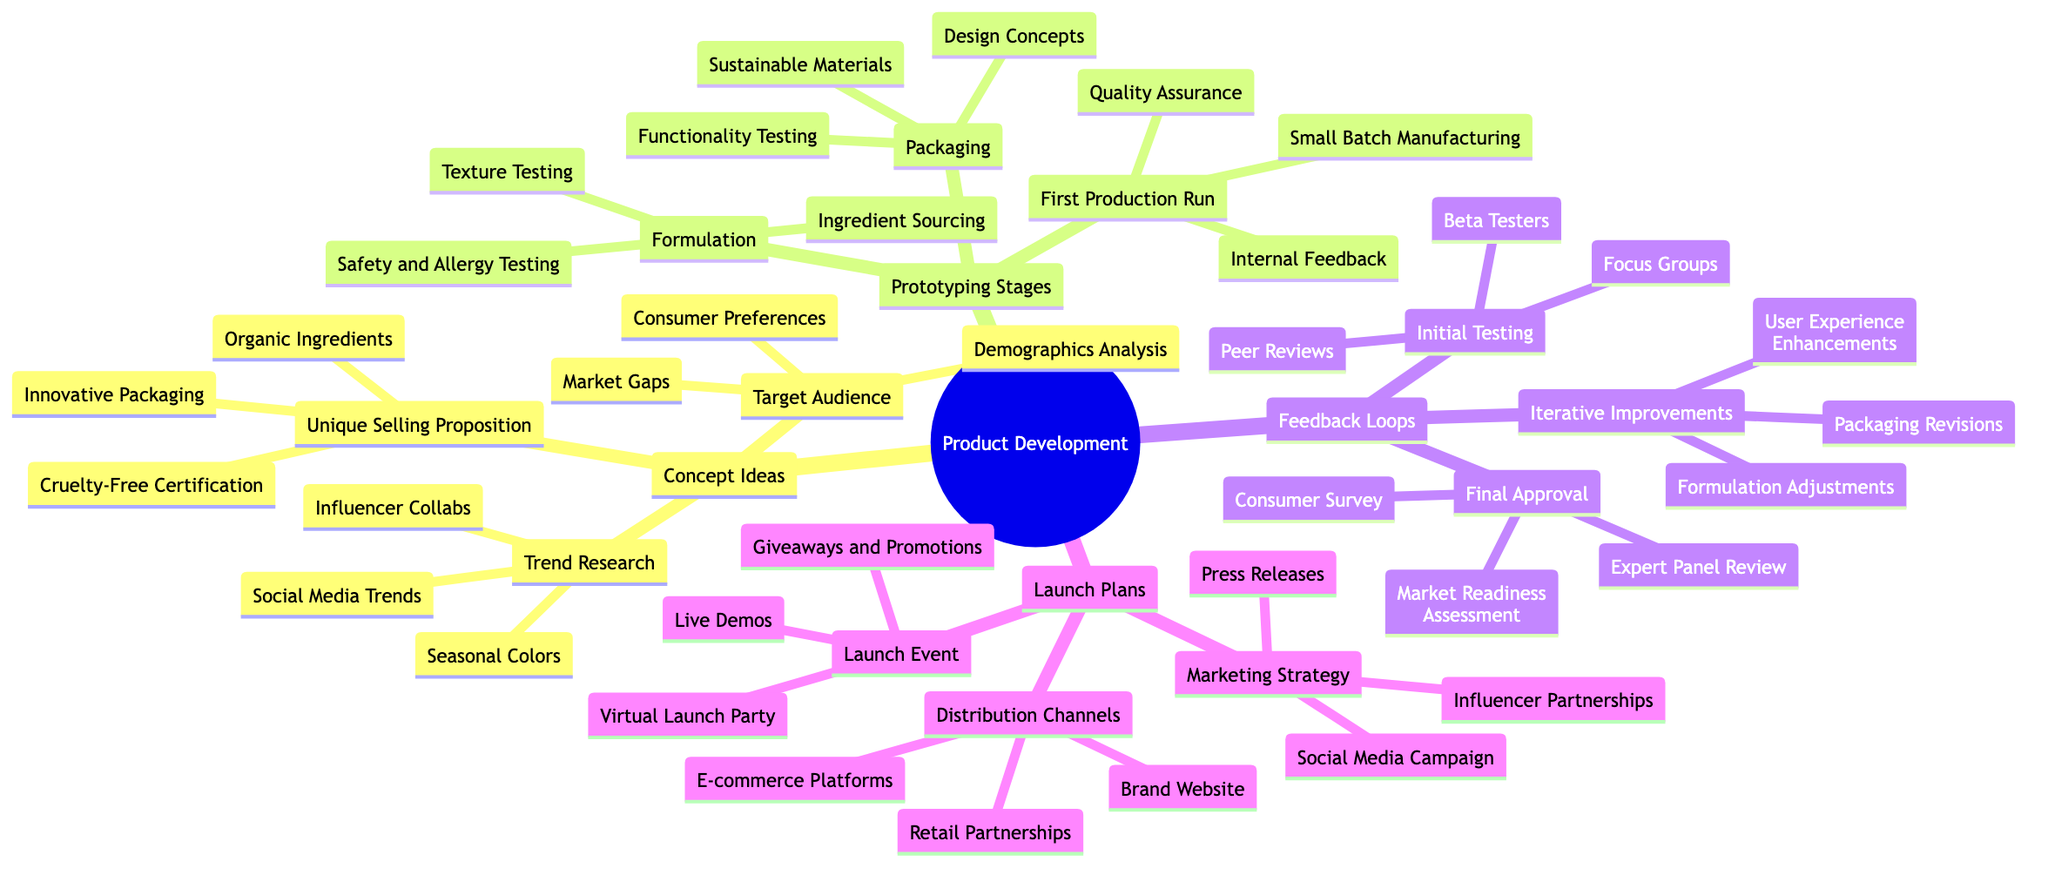What are the three components of Concept Ideas? The three components listed under Concept Ideas are Trend Research, Unique Selling Proposition, and Target Audience.
Answer: Trend Research, Unique Selling Proposition, Target Audience How many items are listed under Prototyping Stages? There are three main nodes under Prototyping Stages: Formulation, Packaging, and First Production Run. Each of these nodes has three associated items, making a total of nine items.
Answer: Nine What is one type of Initial Testing? One type of Initial Testing mentioned is Focus Groups, which helps gather user feedback.
Answer: Focus Groups Which selling proposition emphasizes ethical practices? The Cruelty-Free Certification highlights ethical practices within the Unique Selling Proposition category.
Answer: Cruelty-Free Certification What is the final step in Feedback Loops? The last step listed in Feedback Loops is Final Approval, where the product is reviewed for market readiness.
Answer: Final Approval How are Packaging Revisions categorized? Packaging Revisions fall under Iterative Improvements, indicating ongoing enhancement based on feedback.
Answer: Iterative Improvements What type of event is planned for Launch Plans? A Virtual Launch Party is proposed as part of the Launch Event category, engaging audiences directly online.
Answer: Virtual Launch Party What strategy is commonly used in Launch Plans for outreach? A Social Media Campaign is a key marketing strategy used to promote the beauty line during the launch.
Answer: Social Media Campaign How many unique components are there under Launch Plans? The Launch Plans consist of three unique components: Marketing Strategy, Distribution Channels, and Launch Event.
Answer: Three 